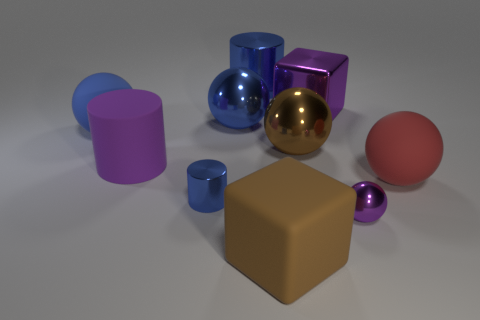How many big brown balls are in front of the matte sphere on the right side of the large rubber ball on the left side of the small purple metal sphere?
Ensure brevity in your answer.  0. Are there more large brown cubes than small gray matte cylinders?
Keep it short and to the point. Yes. What number of red rubber spheres are there?
Offer a very short reply. 1. The small thing to the right of the big brown block in front of the thing that is on the right side of the small purple object is what shape?
Offer a terse response. Sphere. Is the number of large brown spheres in front of the matte cylinder less than the number of large purple cubes in front of the red sphere?
Offer a very short reply. No. There is a purple metal thing behind the purple rubber object; is its shape the same as the matte thing that is to the left of the rubber cylinder?
Your response must be concise. No. What shape is the tiny thing that is right of the big blue sphere right of the blue rubber object?
Provide a short and direct response. Sphere. There is a metal object that is the same color as the matte block; what size is it?
Ensure brevity in your answer.  Large. Are there any cubes that have the same material as the brown ball?
Your answer should be very brief. Yes. What material is the object on the right side of the purple metal ball?
Make the answer very short. Rubber. 